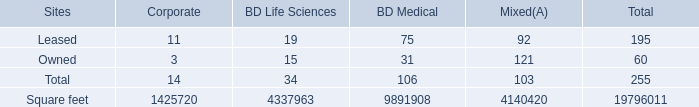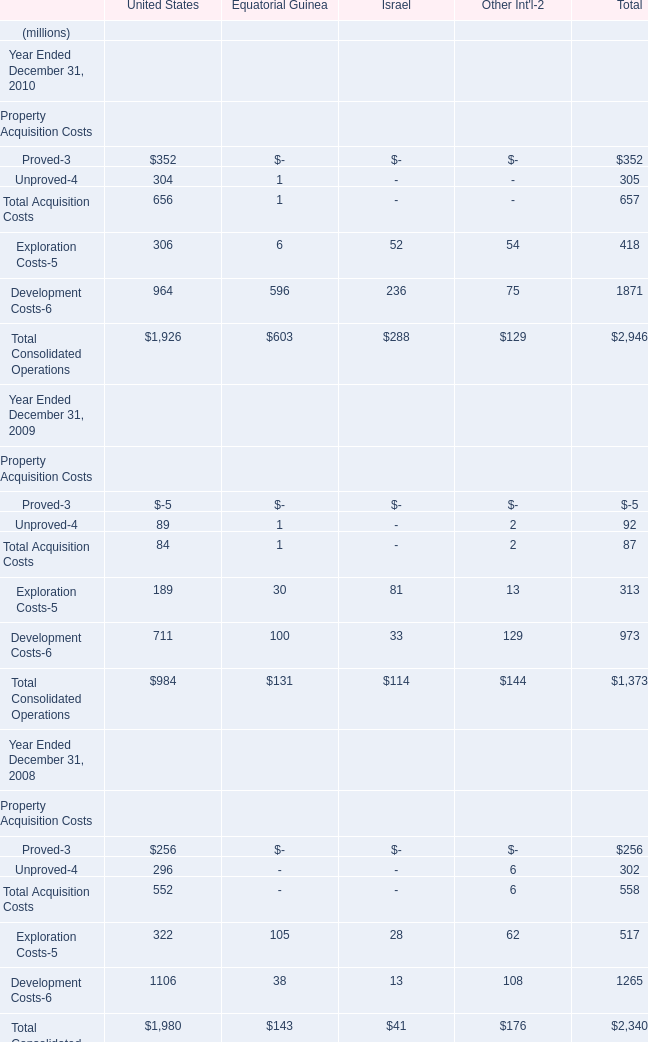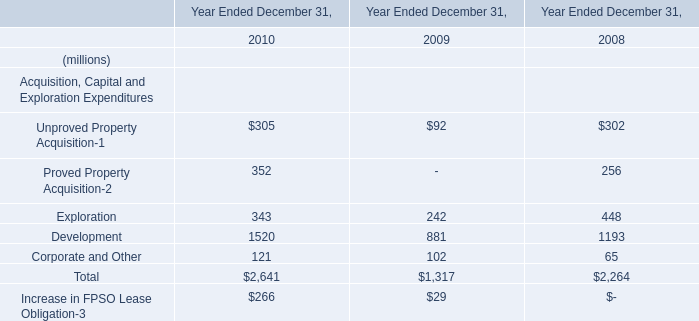what percentage of international facilities' square footage is from owned facilities?\\n 
Computations: (7189652 / (7189652 + 2223245))
Answer: 0.76381. 